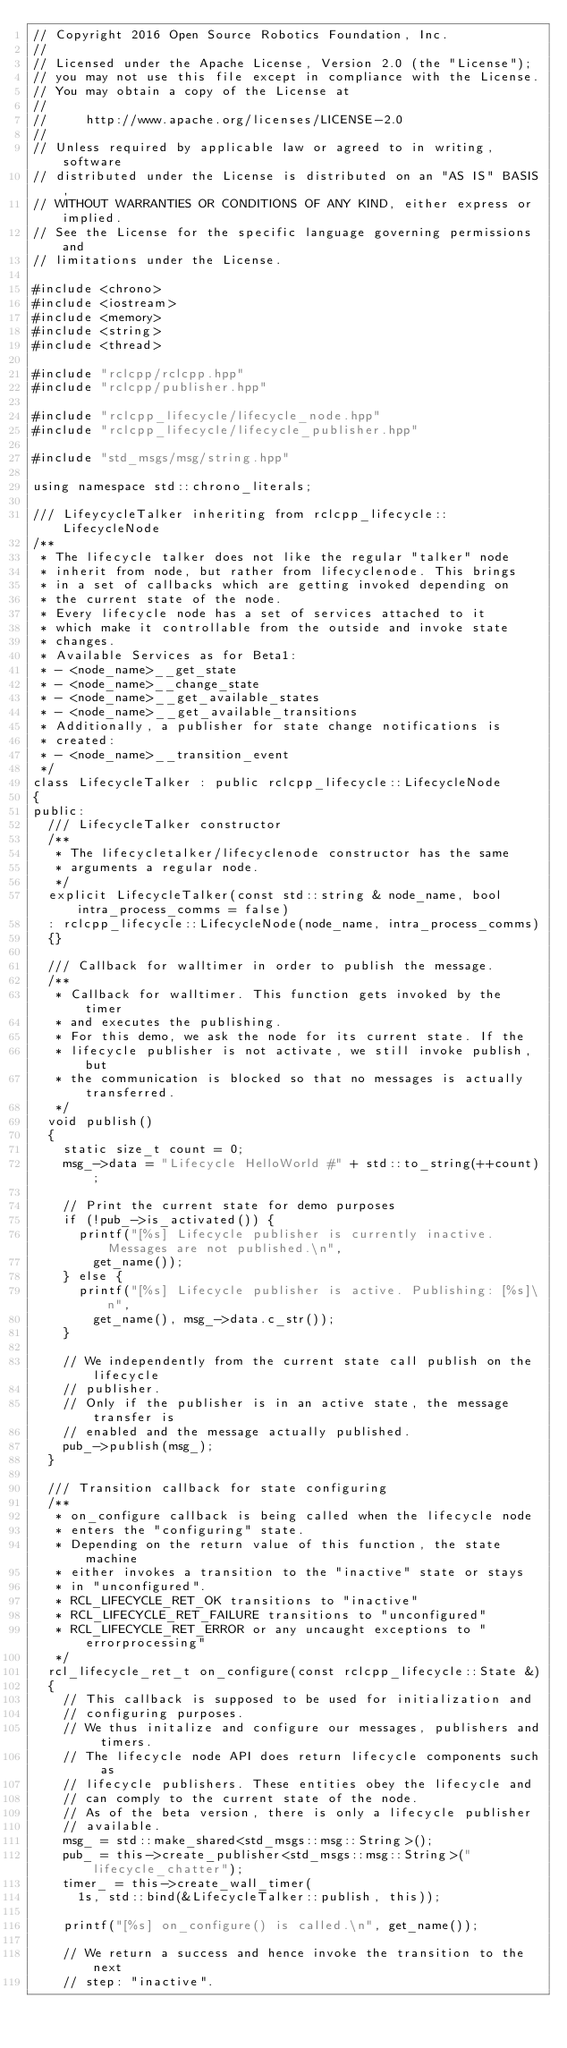Convert code to text. <code><loc_0><loc_0><loc_500><loc_500><_C++_>// Copyright 2016 Open Source Robotics Foundation, Inc.
//
// Licensed under the Apache License, Version 2.0 (the "License");
// you may not use this file except in compliance with the License.
// You may obtain a copy of the License at
//
//     http://www.apache.org/licenses/LICENSE-2.0
//
// Unless required by applicable law or agreed to in writing, software
// distributed under the License is distributed on an "AS IS" BASIS,
// WITHOUT WARRANTIES OR CONDITIONS OF ANY KIND, either express or implied.
// See the License for the specific language governing permissions and
// limitations under the License.

#include <chrono>
#include <iostream>
#include <memory>
#include <string>
#include <thread>

#include "rclcpp/rclcpp.hpp"
#include "rclcpp/publisher.hpp"

#include "rclcpp_lifecycle/lifecycle_node.hpp"
#include "rclcpp_lifecycle/lifecycle_publisher.hpp"

#include "std_msgs/msg/string.hpp"

using namespace std::chrono_literals;

/// LifeycycleTalker inheriting from rclcpp_lifecycle::LifecycleNode
/**
 * The lifecycle talker does not like the regular "talker" node
 * inherit from node, but rather from lifecyclenode. This brings
 * in a set of callbacks which are getting invoked depending on
 * the current state of the node.
 * Every lifecycle node has a set of services attached to it
 * which make it controllable from the outside and invoke state
 * changes.
 * Available Services as for Beta1:
 * - <node_name>__get_state
 * - <node_name>__change_state
 * - <node_name>__get_available_states
 * - <node_name>__get_available_transitions
 * Additionally, a publisher for state change notifications is
 * created:
 * - <node_name>__transition_event
 */
class LifecycleTalker : public rclcpp_lifecycle::LifecycleNode
{
public:
  /// LifecycleTalker constructor
  /**
   * The lifecycletalker/lifecyclenode constructor has the same
   * arguments a regular node.
   */
  explicit LifecycleTalker(const std::string & node_name, bool intra_process_comms = false)
  : rclcpp_lifecycle::LifecycleNode(node_name, intra_process_comms)
  {}

  /// Callback for walltimer in order to publish the message.
  /**
   * Callback for walltimer. This function gets invoked by the timer
   * and executes the publishing.
   * For this demo, we ask the node for its current state. If the
   * lifecycle publisher is not activate, we still invoke publish, but
   * the communication is blocked so that no messages is actually transferred.
   */
  void publish()
  {
    static size_t count = 0;
    msg_->data = "Lifecycle HelloWorld #" + std::to_string(++count);

    // Print the current state for demo purposes
    if (!pub_->is_activated()) {
      printf("[%s] Lifecycle publisher is currently inactive. Messages are not published.\n",
        get_name());
    } else {
      printf("[%s] Lifecycle publisher is active. Publishing: [%s]\n",
        get_name(), msg_->data.c_str());
    }

    // We independently from the current state call publish on the lifecycle
    // publisher.
    // Only if the publisher is in an active state, the message transfer is
    // enabled and the message actually published.
    pub_->publish(msg_);
  }

  /// Transition callback for state configuring
  /**
   * on_configure callback is being called when the lifecycle node
   * enters the "configuring" state.
   * Depending on the return value of this function, the state machine
   * either invokes a transition to the "inactive" state or stays
   * in "unconfigured".
   * RCL_LIFECYCLE_RET_OK transitions to "inactive"
   * RCL_LIFECYCLE_RET_FAILURE transitions to "unconfigured"
   * RCL_LIFECYCLE_RET_ERROR or any uncaught exceptions to "errorprocessing"
   */
  rcl_lifecycle_ret_t on_configure(const rclcpp_lifecycle::State &)
  {
    // This callback is supposed to be used for initialization and
    // configuring purposes.
    // We thus initalize and configure our messages, publishers and timers.
    // The lifecycle node API does return lifecycle components such as
    // lifecycle publishers. These entities obey the lifecycle and
    // can comply to the current state of the node.
    // As of the beta version, there is only a lifecycle publisher
    // available.
    msg_ = std::make_shared<std_msgs::msg::String>();
    pub_ = this->create_publisher<std_msgs::msg::String>("lifecycle_chatter");
    timer_ = this->create_wall_timer(
      1s, std::bind(&LifecycleTalker::publish, this));

    printf("[%s] on_configure() is called.\n", get_name());

    // We return a success and hence invoke the transition to the next
    // step: "inactive".</code> 